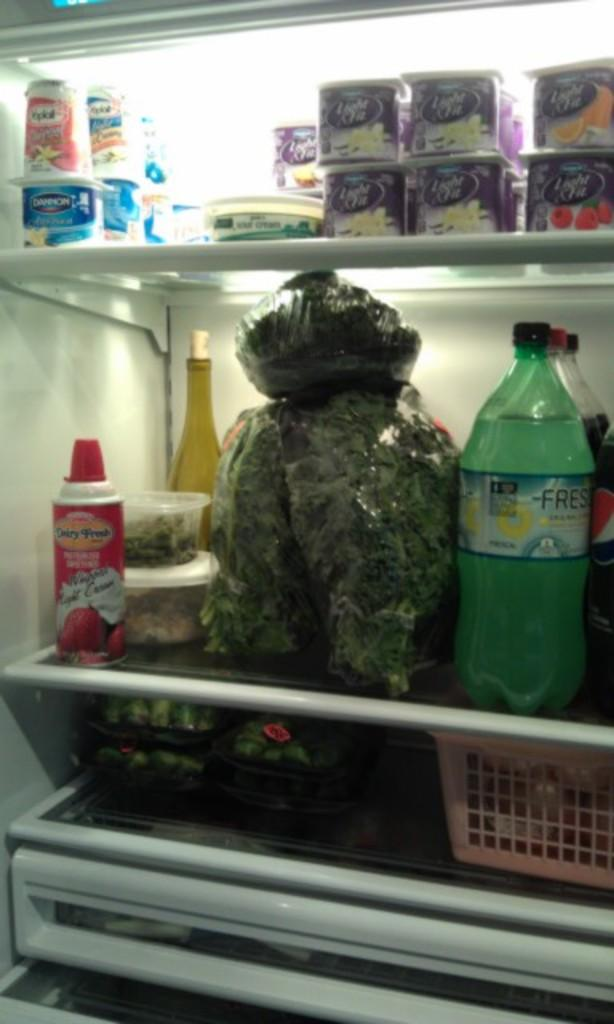What type of containers are present in the image? There are boxes in the image. What else can be seen in the image besides the boxes? There are different types of bottles filled with liquid and vegetables in the image. How are these items arranged in the image? The arrangement of these items resembles a refrigerator. What type of organization is responsible for the seed in the image? There is no seed present in the image, so it is not possible to determine which organization might be responsible for it. 